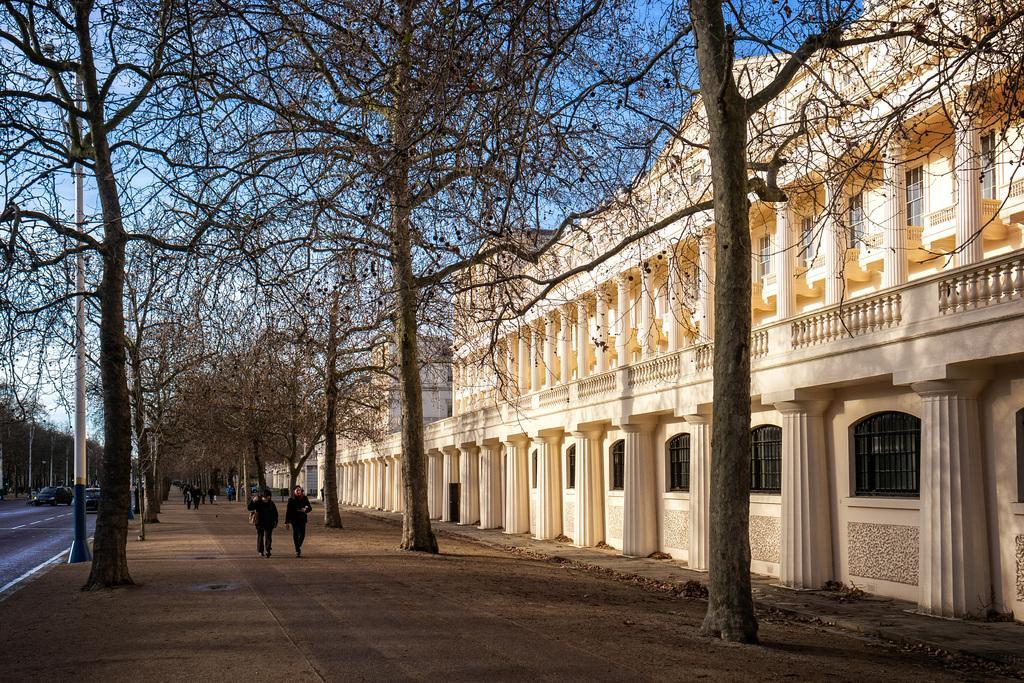Describe this image in one or two sentences. In this image, we can see a white building with walls, pillars and glass windows. At the bottom, we can see a group of people. Few are walking on the walkway. There are so many trees, poles, vehicles on the road. Background there is a sky. 